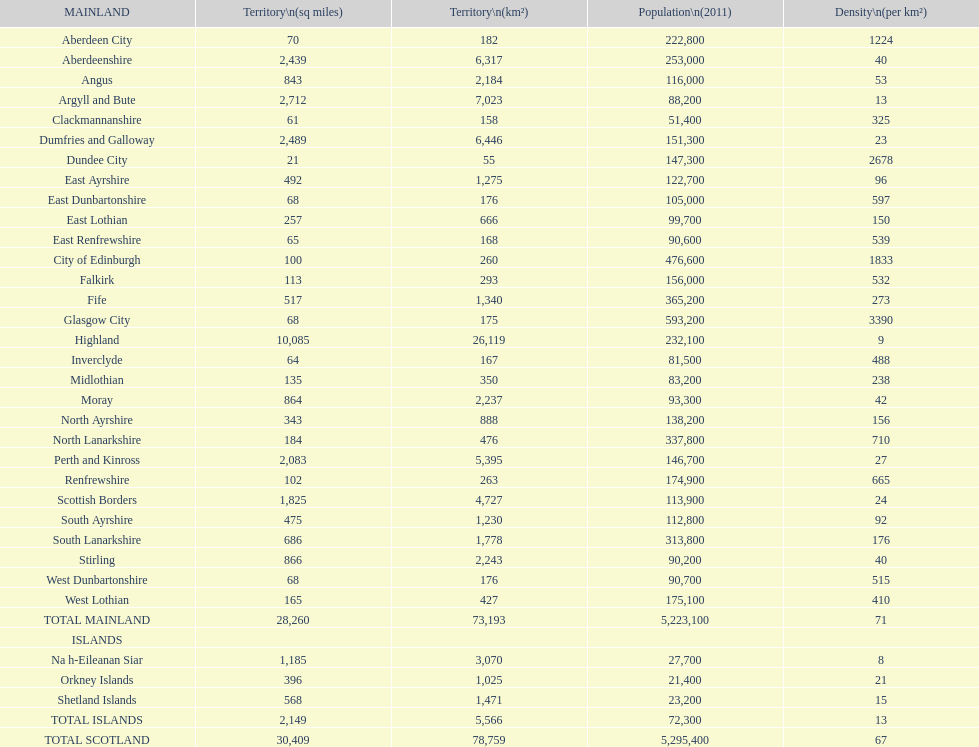What is the sum of the areas of east lothian, angus, and dundee city? 1121. 